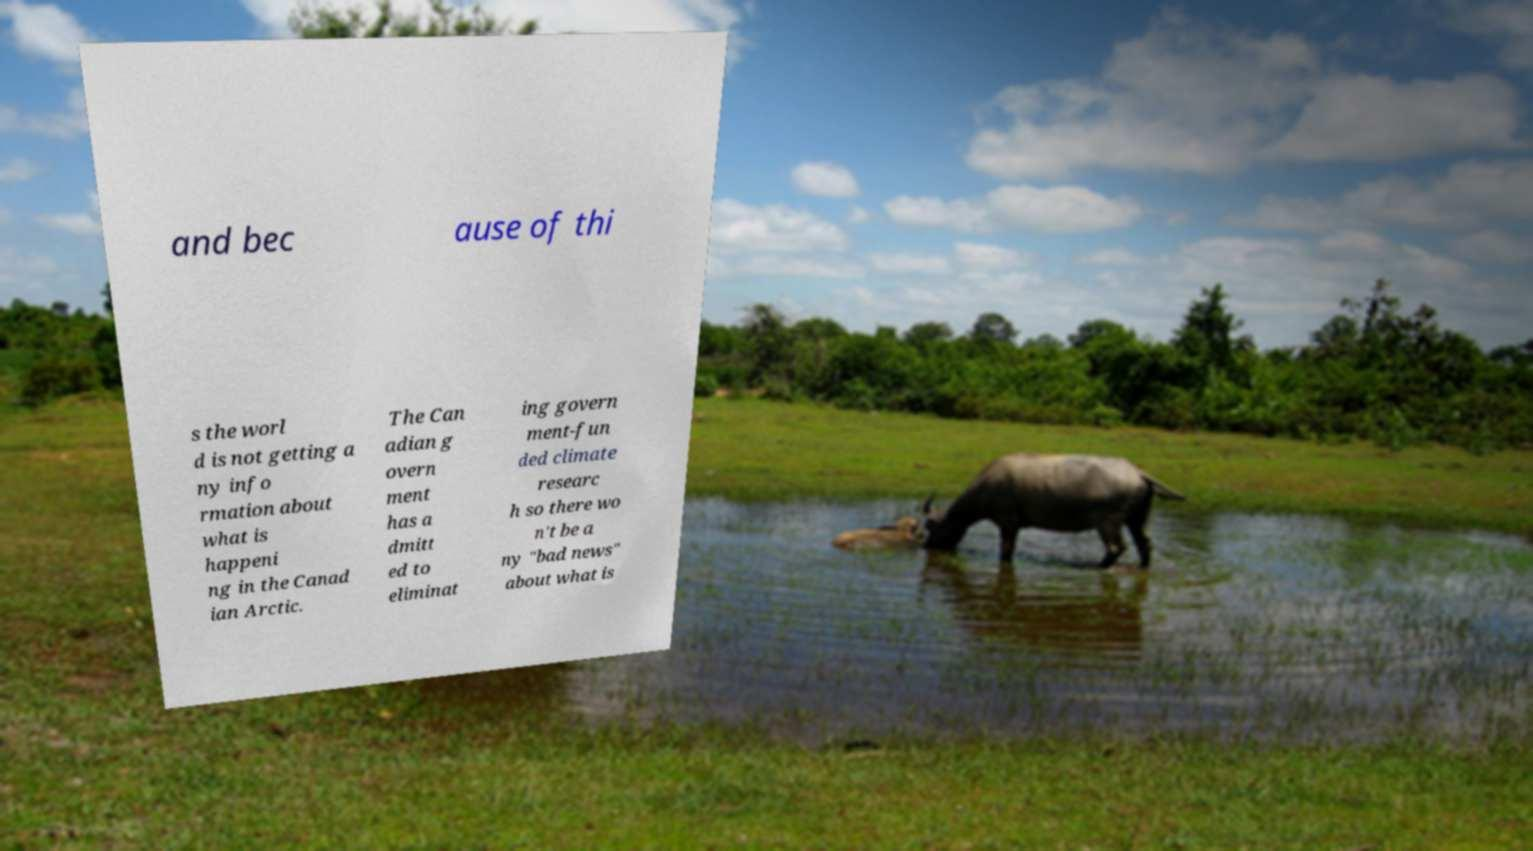There's text embedded in this image that I need extracted. Can you transcribe it verbatim? and bec ause of thi s the worl d is not getting a ny info rmation about what is happeni ng in the Canad ian Arctic. The Can adian g overn ment has a dmitt ed to eliminat ing govern ment-fun ded climate researc h so there wo n't be a ny "bad news" about what is 